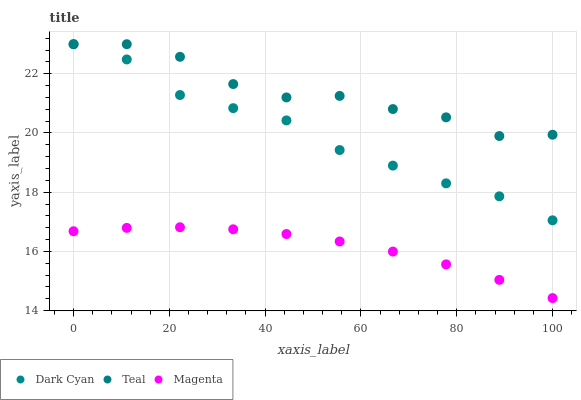Does Magenta have the minimum area under the curve?
Answer yes or no. Yes. Does Teal have the maximum area under the curve?
Answer yes or no. Yes. Does Teal have the minimum area under the curve?
Answer yes or no. No. Does Magenta have the maximum area under the curve?
Answer yes or no. No. Is Magenta the smoothest?
Answer yes or no. Yes. Is Teal the roughest?
Answer yes or no. Yes. Is Teal the smoothest?
Answer yes or no. No. Is Magenta the roughest?
Answer yes or no. No. Does Magenta have the lowest value?
Answer yes or no. Yes. Does Teal have the lowest value?
Answer yes or no. No. Does Teal have the highest value?
Answer yes or no. Yes. Does Magenta have the highest value?
Answer yes or no. No. Is Magenta less than Dark Cyan?
Answer yes or no. Yes. Is Dark Cyan greater than Magenta?
Answer yes or no. Yes. Does Dark Cyan intersect Teal?
Answer yes or no. Yes. Is Dark Cyan less than Teal?
Answer yes or no. No. Is Dark Cyan greater than Teal?
Answer yes or no. No. Does Magenta intersect Dark Cyan?
Answer yes or no. No. 